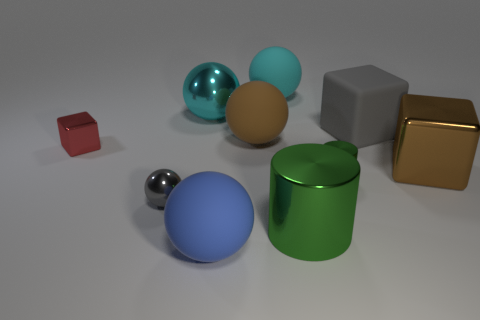Subtract 1 spheres. How many spheres are left? 4 Subtract all cyan spheres. How many spheres are left? 3 Subtract all big blue rubber balls. How many balls are left? 4 Subtract all gray balls. Subtract all brown cylinders. How many balls are left? 4 Subtract all blocks. How many objects are left? 7 Subtract 0 cyan cylinders. How many objects are left? 10 Subtract all matte balls. Subtract all large blue spheres. How many objects are left? 6 Add 3 metallic objects. How many metallic objects are left? 9 Add 2 large brown metal things. How many large brown metal things exist? 3 